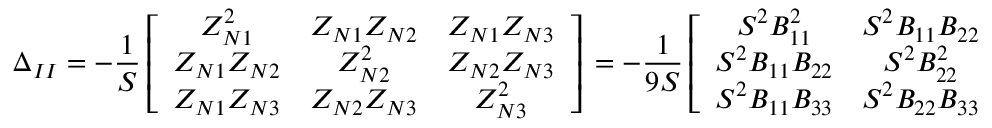<formula> <loc_0><loc_0><loc_500><loc_500>\Delta _ { I I } = - \frac { 1 } { S } \left [ \begin{array} { c c c } { Z _ { N 1 } ^ { 2 } } & { Z _ { N 1 } Z _ { N 2 } } & { Z _ { N 1 } Z _ { N 3 } } \\ { Z _ { N 1 } Z _ { N 2 } } & { Z _ { N 2 } ^ { 2 } } & { Z _ { N 2 } Z _ { N 3 } } \\ { Z _ { N 1 } Z _ { N 3 } } & { Z _ { N 2 } Z _ { N 3 } } & { Z _ { N 3 } ^ { 2 } } \end{array} \right ] \, = - \frac { 1 } { 9 S } \left [ \begin{array} { c c c } { S ^ { 2 } B _ { 1 1 } ^ { 2 } } & { S ^ { 2 } B _ { 1 1 } B _ { 2 2 } } & { S ^ { 2 } B _ { 1 1 } B _ { 3 3 } } \\ { S ^ { 2 } B _ { 1 1 } B _ { 2 2 } } & { S ^ { 2 } B _ { 2 2 } ^ { 2 } } & { S ^ { 2 } B _ { 2 2 } B _ { 3 3 } } \\ { S ^ { 2 } B _ { 1 1 } B _ { 3 3 } } & { S ^ { 2 } B _ { 2 2 } B _ { 3 3 } } & { S ^ { 2 } B _ { 3 3 } ^ { 2 } } \end{array} \right ] \, ,</formula> 